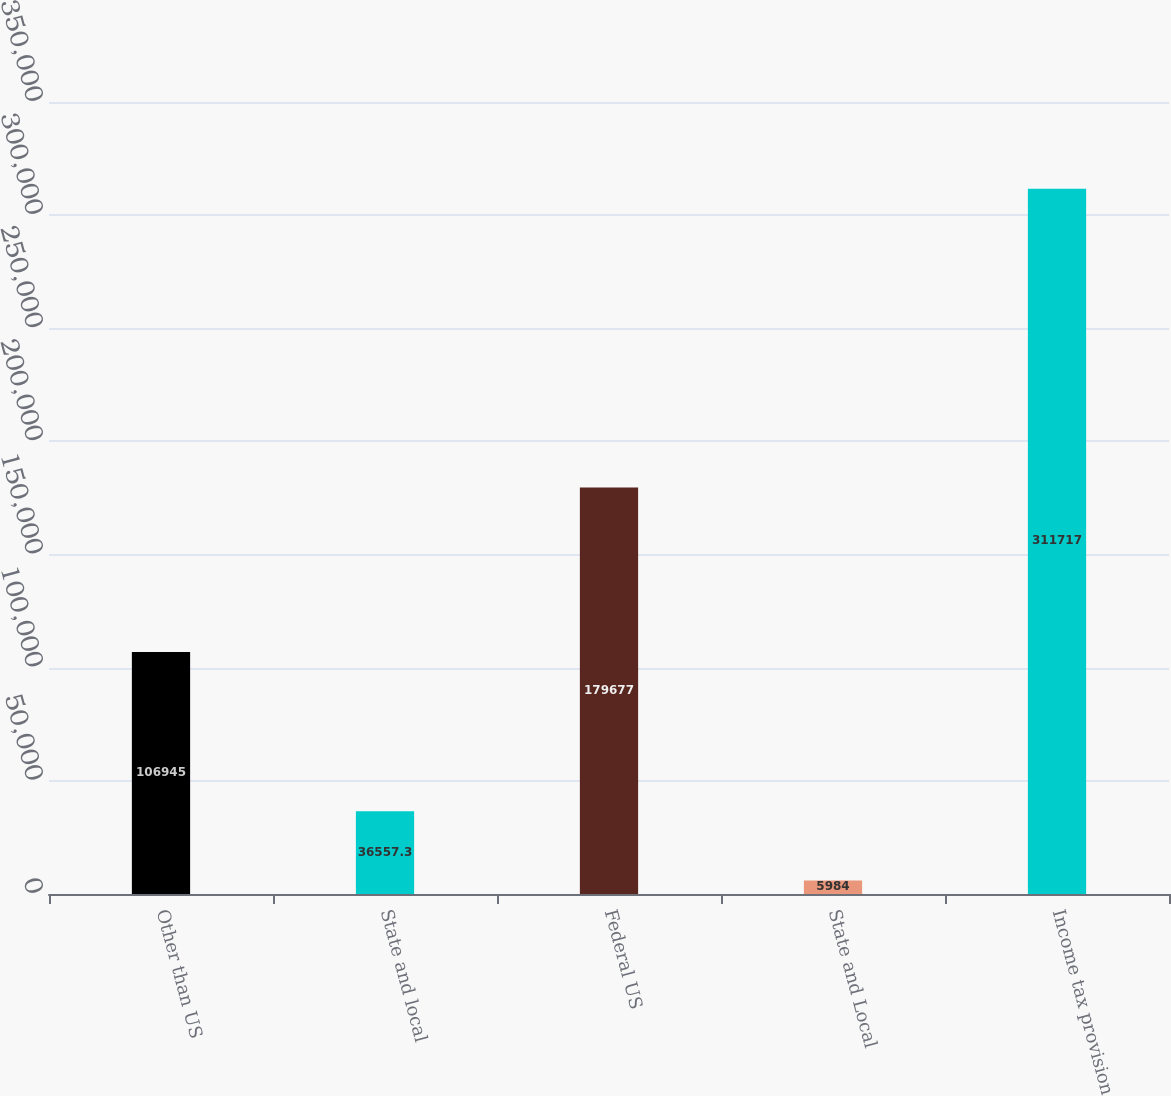Convert chart. <chart><loc_0><loc_0><loc_500><loc_500><bar_chart><fcel>Other than US<fcel>State and local<fcel>Federal US<fcel>State and Local<fcel>Income tax provision<nl><fcel>106945<fcel>36557.3<fcel>179677<fcel>5984<fcel>311717<nl></chart> 